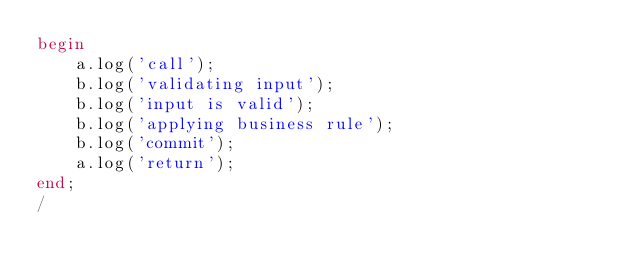Convert code to text. <code><loc_0><loc_0><loc_500><loc_500><_SQL_>begin
    a.log('call');
    b.log('validating input');
    b.log('input is valid');
    b.log('applying business rule');
    b.log('commit');
    a.log('return');
end;
/
</code> 